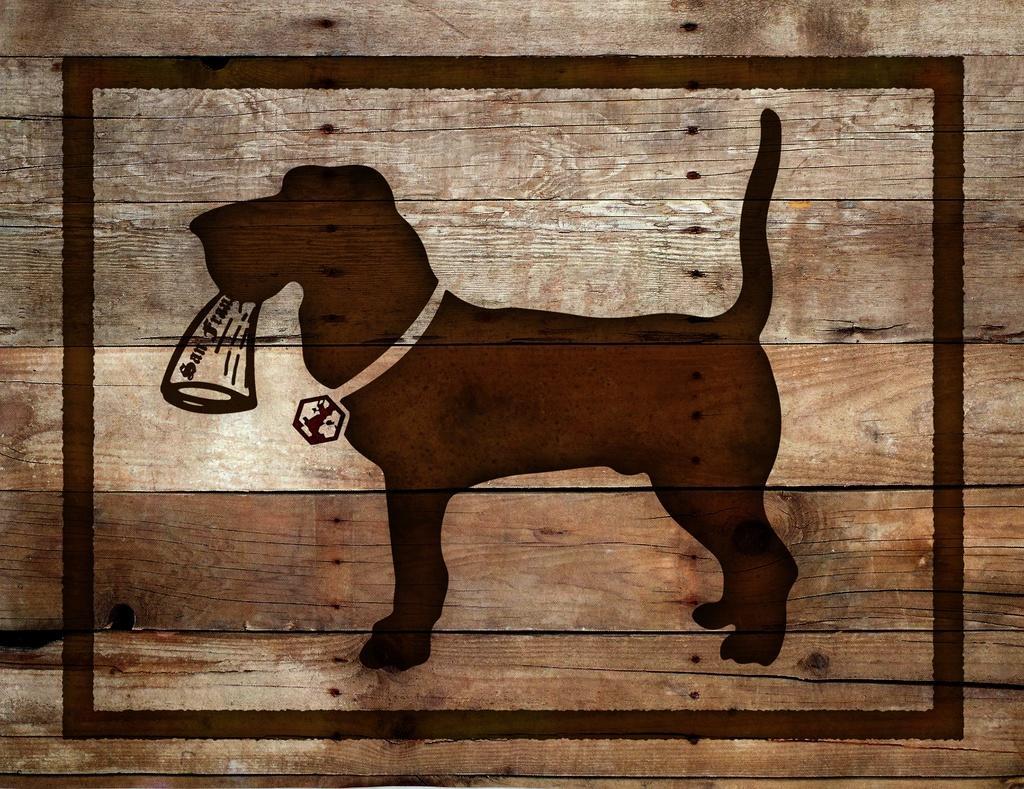Could you give a brief overview of what you see in this image? Here in this picture we can see a wooden wall and on that we can see a dog design over there and we can see it is holding something and having belt on its neck over there. 